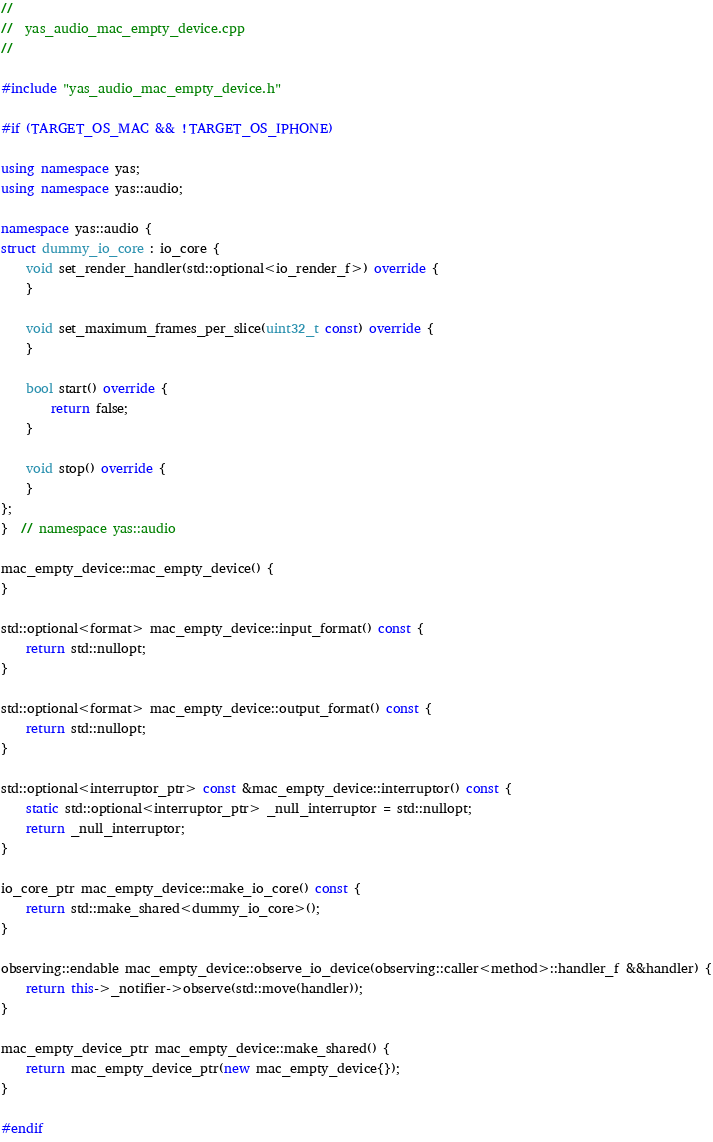Convert code to text. <code><loc_0><loc_0><loc_500><loc_500><_C++_>//
//  yas_audio_mac_empty_device.cpp
//

#include "yas_audio_mac_empty_device.h"

#if (TARGET_OS_MAC && !TARGET_OS_IPHONE)

using namespace yas;
using namespace yas::audio;

namespace yas::audio {
struct dummy_io_core : io_core {
    void set_render_handler(std::optional<io_render_f>) override {
    }

    void set_maximum_frames_per_slice(uint32_t const) override {
    }

    bool start() override {
        return false;
    }

    void stop() override {
    }
};
}  // namespace yas::audio

mac_empty_device::mac_empty_device() {
}

std::optional<format> mac_empty_device::input_format() const {
    return std::nullopt;
}

std::optional<format> mac_empty_device::output_format() const {
    return std::nullopt;
}

std::optional<interruptor_ptr> const &mac_empty_device::interruptor() const {
    static std::optional<interruptor_ptr> _null_interruptor = std::nullopt;
    return _null_interruptor;
}

io_core_ptr mac_empty_device::make_io_core() const {
    return std::make_shared<dummy_io_core>();
}

observing::endable mac_empty_device::observe_io_device(observing::caller<method>::handler_f &&handler) {
    return this->_notifier->observe(std::move(handler));
}

mac_empty_device_ptr mac_empty_device::make_shared() {
    return mac_empty_device_ptr(new mac_empty_device{});
}

#endif
</code> 